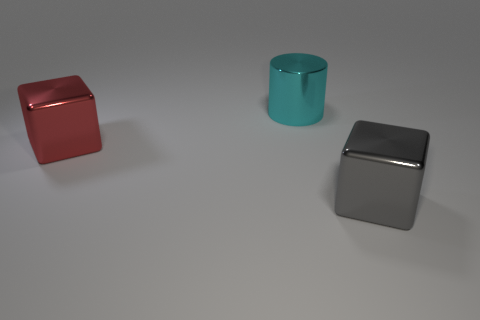Are there more big metal things in front of the big cyan shiny thing than gray metal cubes that are on the left side of the big gray block?
Make the answer very short. Yes. What number of metallic blocks are in front of the block in front of the red shiny block?
Provide a short and direct response. 0. Is there a metal thing of the same color as the shiny cylinder?
Ensure brevity in your answer.  No. Do the cyan object and the gray thing have the same size?
Keep it short and to the point. Yes. There is a large block to the left of the large shiny block that is in front of the red metallic block; what is it made of?
Your answer should be compact. Metal. There is another object that is the same shape as the gray thing; what is it made of?
Ensure brevity in your answer.  Metal. Do the cube that is left of the gray metallic block and the cyan thing have the same size?
Provide a succinct answer. Yes. How many matte objects are either small red things or gray things?
Provide a short and direct response. 0. What is the material of the big thing that is both to the left of the gray metallic block and in front of the cyan thing?
Ensure brevity in your answer.  Metal. Is the large red block made of the same material as the cyan cylinder?
Provide a succinct answer. Yes. 